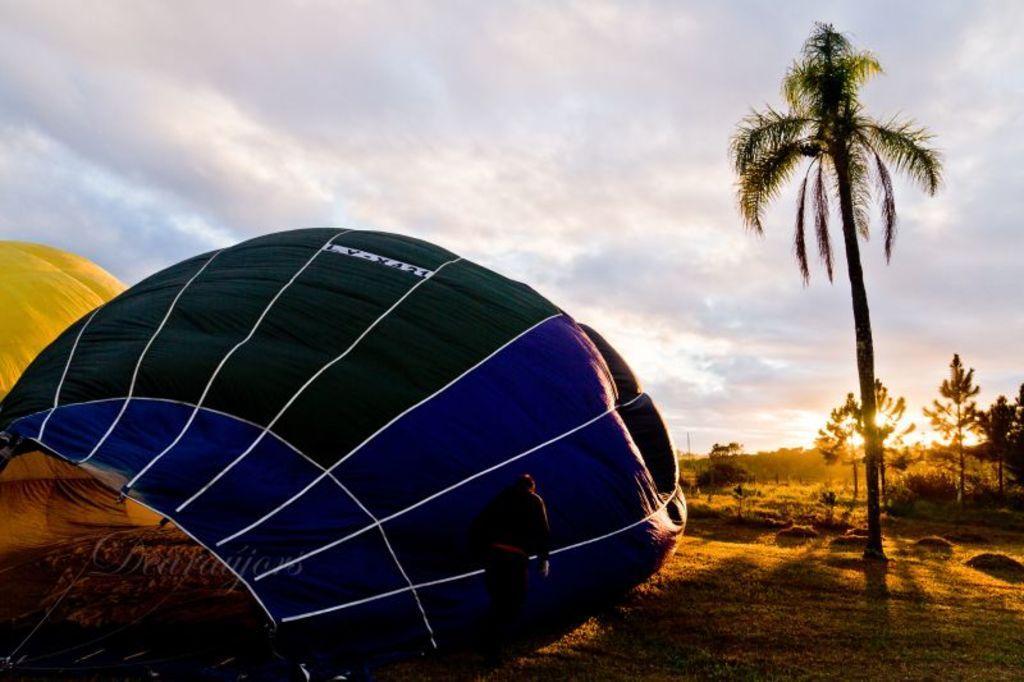Can you describe this image briefly? In this picture, we can see parachute, a person, the ground, trees, grass, plants, and the sky with clouds, and the sun. 